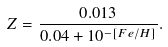Convert formula to latex. <formula><loc_0><loc_0><loc_500><loc_500>Z = \frac { 0 . 0 1 3 } { 0 . 0 4 + 1 0 ^ { - [ F e / H ] } } .</formula> 